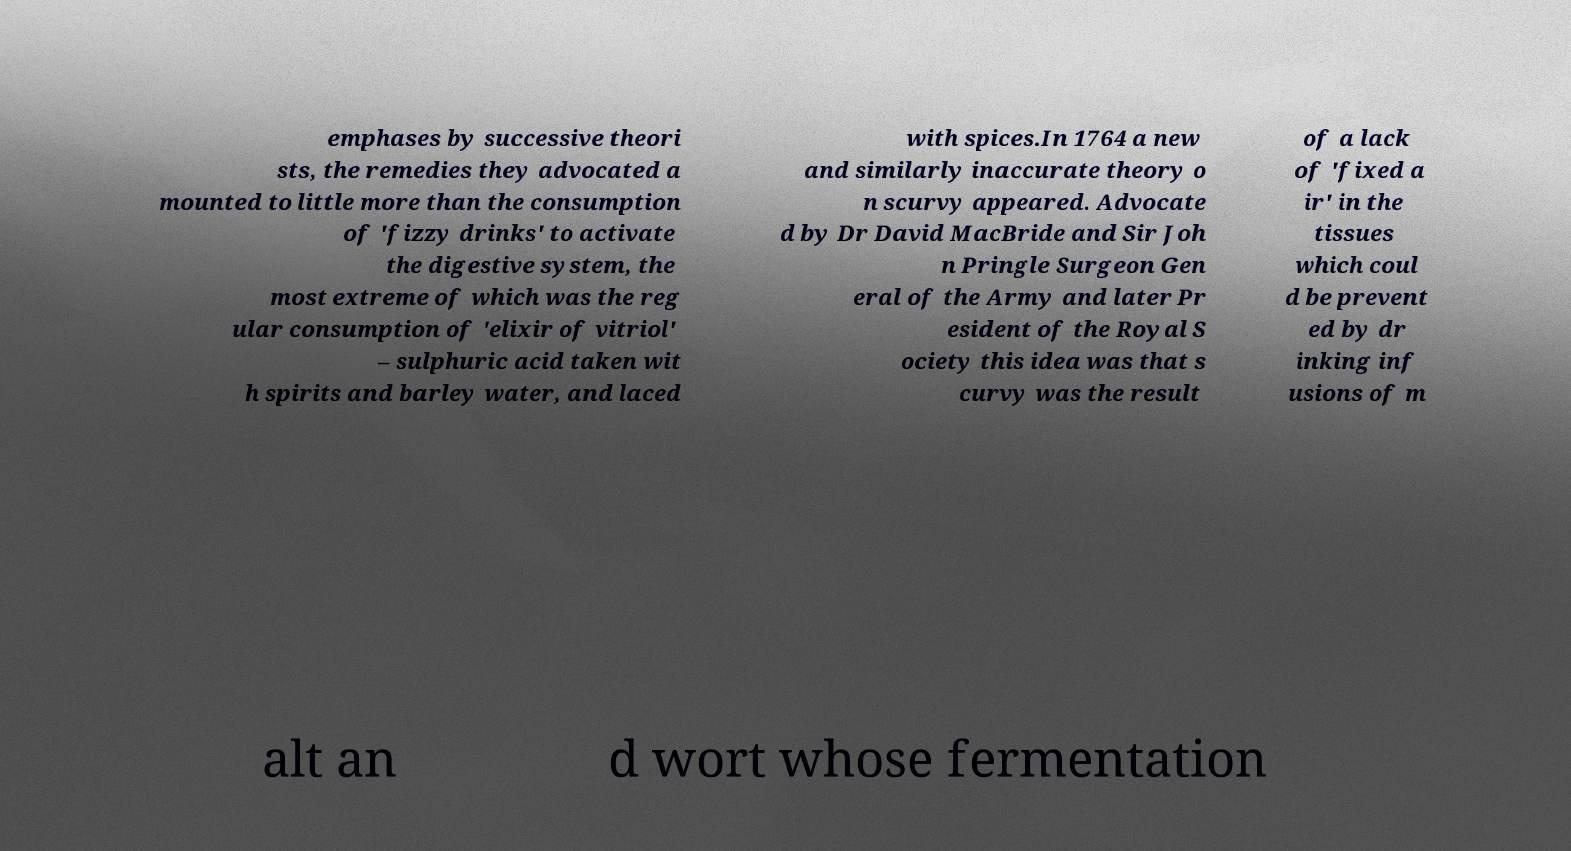What messages or text are displayed in this image? I need them in a readable, typed format. emphases by successive theori sts, the remedies they advocated a mounted to little more than the consumption of 'fizzy drinks' to activate the digestive system, the most extreme of which was the reg ular consumption of 'elixir of vitriol' – sulphuric acid taken wit h spirits and barley water, and laced with spices.In 1764 a new and similarly inaccurate theory o n scurvy appeared. Advocate d by Dr David MacBride and Sir Joh n Pringle Surgeon Gen eral of the Army and later Pr esident of the Royal S ociety this idea was that s curvy was the result of a lack of 'fixed a ir' in the tissues which coul d be prevent ed by dr inking inf usions of m alt an d wort whose fermentation 